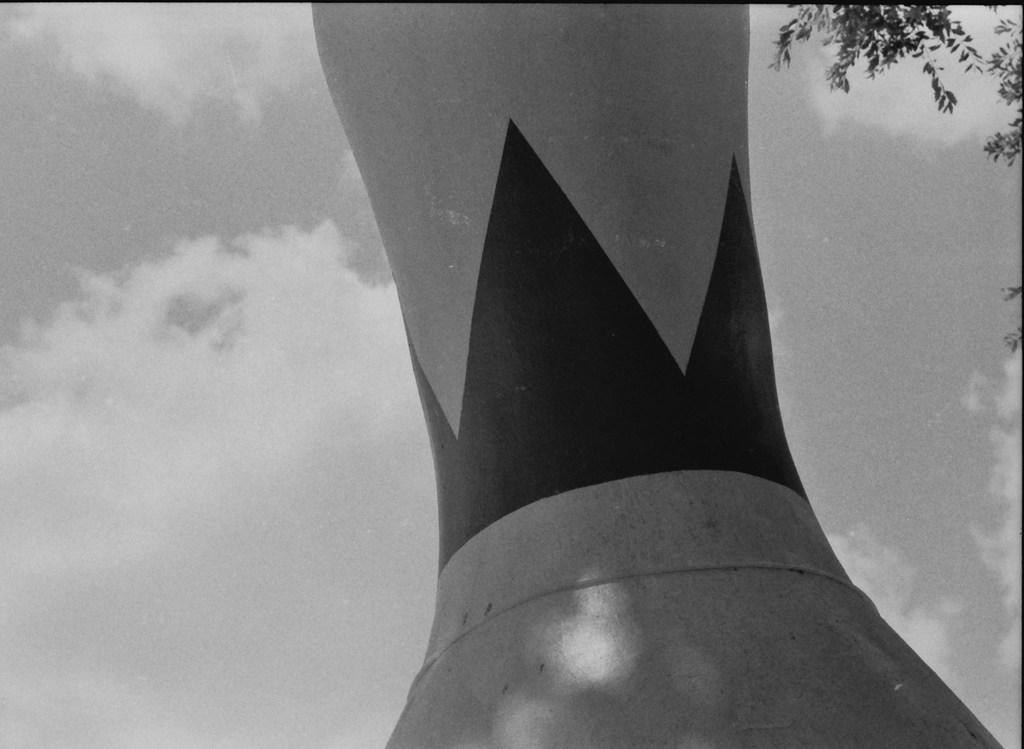What is the color scheme of the image? The image is black and white. What is the main structure in the image? There is a tower in the image. What other natural elements are present in the image? There are branches of a tree beside the tower. What type of lead can be seen connecting the branches of the tree in the image? There is no lead present in the image, as it is a black and white image of a tower and tree branches. What religious symbol can be seen on top of the tower in the image? There is no religious symbol visible on top of the tower in the image, as it is a simple structure with no additional details. 